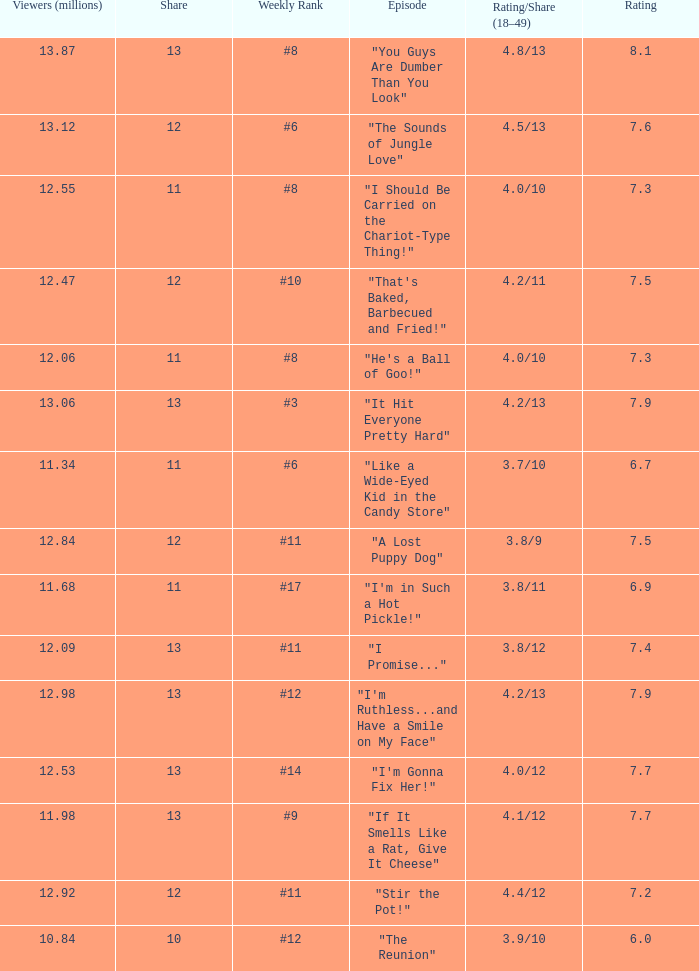What is the average rating for "a lost puppy dog"? 7.5. Write the full table. {'header': ['Viewers (millions)', 'Share', 'Weekly Rank', 'Episode', 'Rating/Share (18–49)', 'Rating'], 'rows': [['13.87', '13', '#8', '"You Guys Are Dumber Than You Look"', '4.8/13', '8.1'], ['13.12', '12', '#6', '"The Sounds of Jungle Love"', '4.5/13', '7.6'], ['12.55', '11', '#8', '"I Should Be Carried on the Chariot-Type Thing!"', '4.0/10', '7.3'], ['12.47', '12', '#10', '"That\'s Baked, Barbecued and Fried!"', '4.2/11', '7.5'], ['12.06', '11', '#8', '"He\'s a Ball of Goo!"', '4.0/10', '7.3'], ['13.06', '13', '#3', '"It Hit Everyone Pretty Hard"', '4.2/13', '7.9'], ['11.34', '11', '#6', '"Like a Wide-Eyed Kid in the Candy Store"', '3.7/10', '6.7'], ['12.84', '12', '#11', '"A Lost Puppy Dog"', '3.8/9', '7.5'], ['11.68', '11', '#17', '"I\'m in Such a Hot Pickle!"', '3.8/11', '6.9'], ['12.09', '13', '#11', '"I Promise..."', '3.8/12', '7.4'], ['12.98', '13', '#12', '"I\'m Ruthless...and Have a Smile on My Face"', '4.2/13', '7.9'], ['12.53', '13', '#14', '"I\'m Gonna Fix Her!"', '4.0/12', '7.7'], ['11.98', '13', '#9', '"If It Smells Like a Rat, Give It Cheese"', '4.1/12', '7.7'], ['12.92', '12', '#11', '"Stir the Pot!"', '4.4/12', '7.2'], ['10.84', '10', '#12', '"The Reunion"', '3.9/10', '6.0']]} 